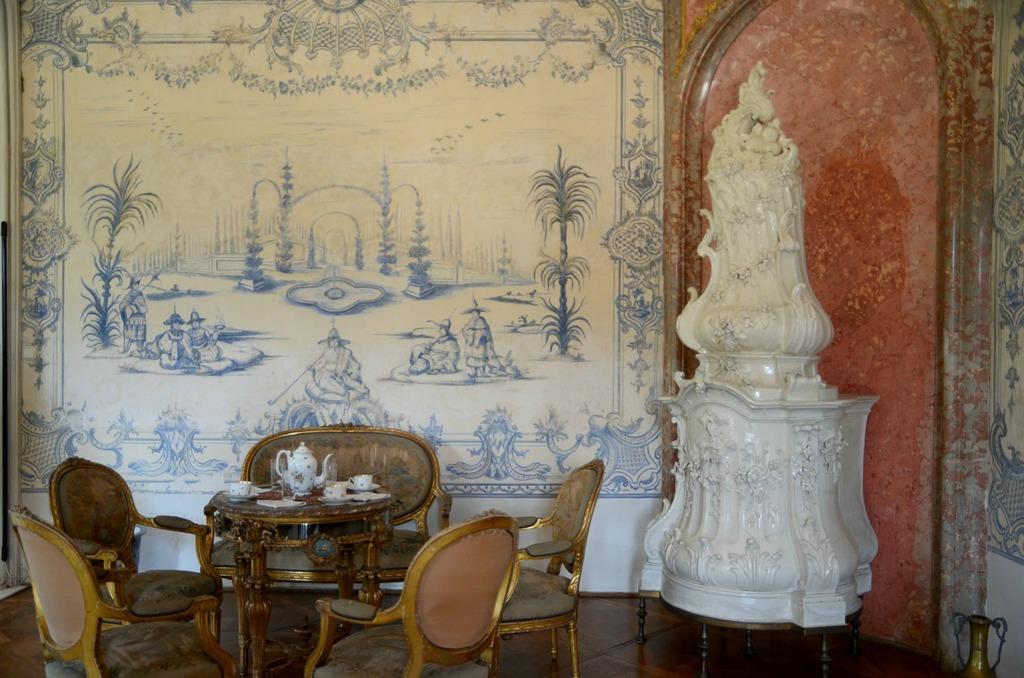Can you describe this image briefly? In the foreground of this image, there is a stone sculpture. Beside it, there are chairs, a table on which, there are cups, jar and few more objects. Behind it, there is a wall. 